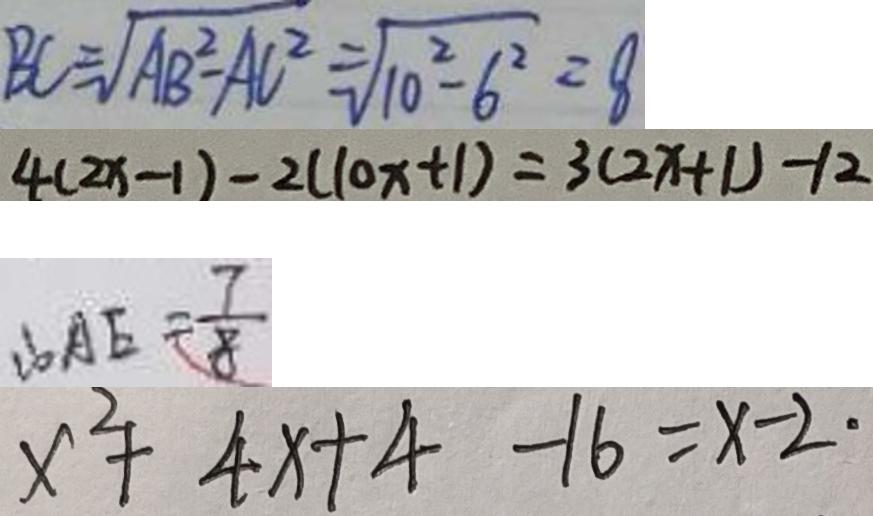Convert formula to latex. <formula><loc_0><loc_0><loc_500><loc_500>B C = \sqrt { A B ^ { 2 } - A C ^ { 2 } } = \sqrt { 1 0 ^ { 2 } - 6 ^ { 2 } } = 8 
 4 ( 2 x - 1 ) - 2 ( 1 0 x + 1 ) = 3 ( 2 x + 1 ) - 1 2 
 \therefore A E = \frac { 7 } { 8 } 
 x ^ { 2 } + 4 x + 4 - 1 6 = x - 2 \cdot</formula> 